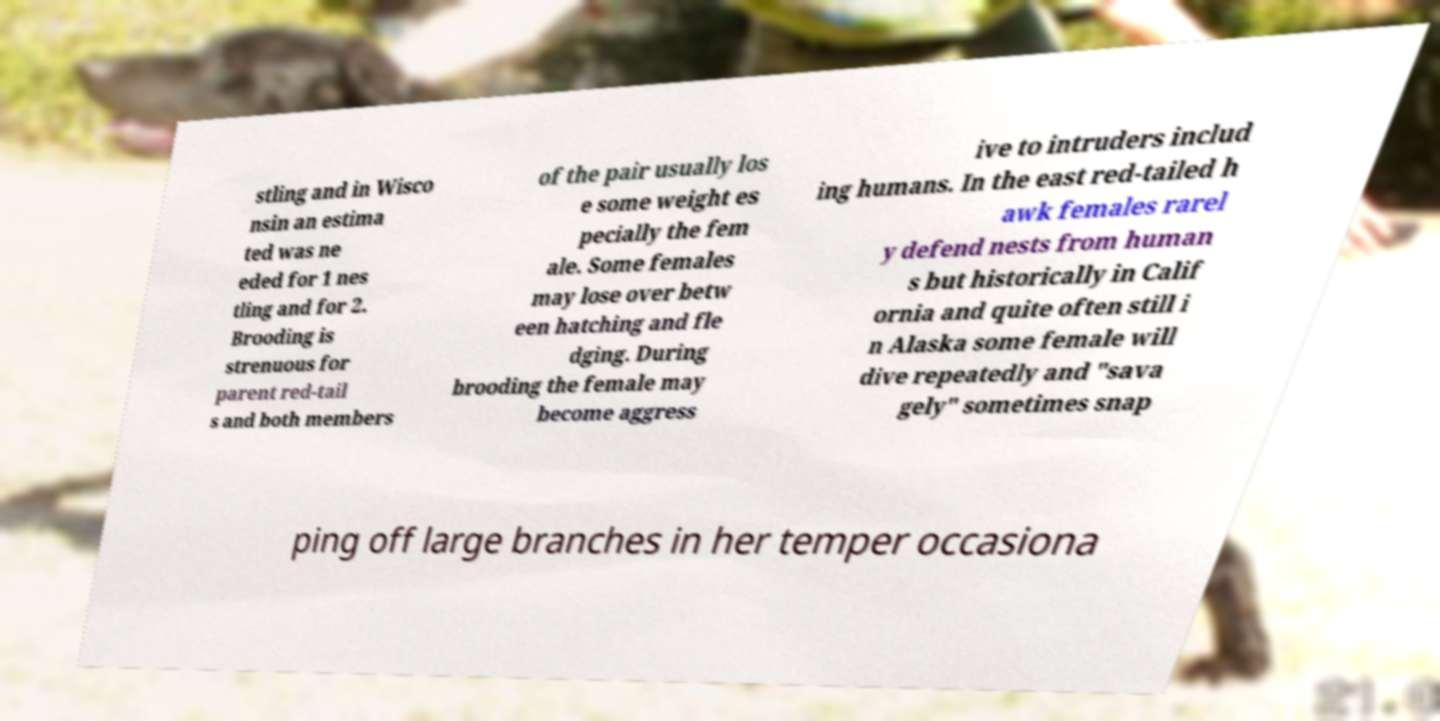Could you extract and type out the text from this image? stling and in Wisco nsin an estima ted was ne eded for 1 nes tling and for 2. Brooding is strenuous for parent red-tail s and both members of the pair usually los e some weight es pecially the fem ale. Some females may lose over betw een hatching and fle dging. During brooding the female may become aggress ive to intruders includ ing humans. In the east red-tailed h awk females rarel y defend nests from human s but historically in Calif ornia and quite often still i n Alaska some female will dive repeatedly and "sava gely" sometimes snap ping off large branches in her temper occasiona 